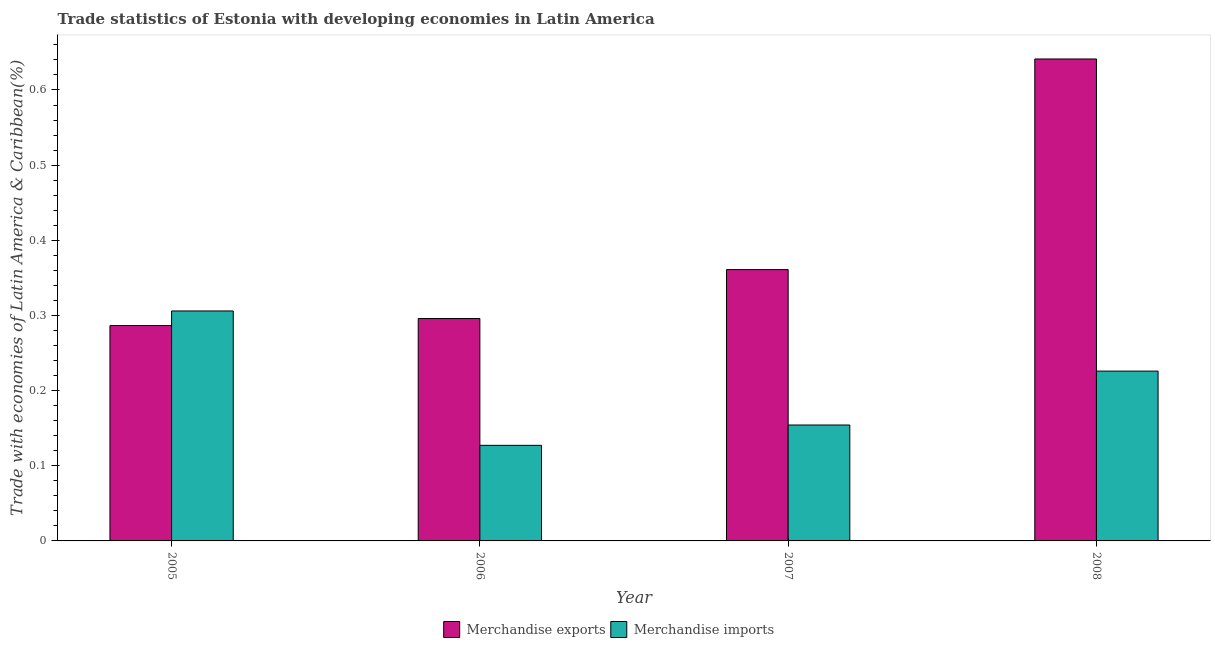How many groups of bars are there?
Keep it short and to the point. 4. How many bars are there on the 4th tick from the right?
Offer a terse response. 2. What is the label of the 2nd group of bars from the left?
Provide a short and direct response. 2006. In how many cases, is the number of bars for a given year not equal to the number of legend labels?
Your answer should be very brief. 0. What is the merchandise exports in 2007?
Your response must be concise. 0.36. Across all years, what is the maximum merchandise imports?
Provide a succinct answer. 0.31. Across all years, what is the minimum merchandise imports?
Provide a short and direct response. 0.13. What is the total merchandise imports in the graph?
Your answer should be compact. 0.81. What is the difference between the merchandise exports in 2005 and that in 2007?
Give a very brief answer. -0.07. What is the difference between the merchandise imports in 2006 and the merchandise exports in 2007?
Keep it short and to the point. -0.03. What is the average merchandise imports per year?
Give a very brief answer. 0.2. In the year 2008, what is the difference between the merchandise imports and merchandise exports?
Ensure brevity in your answer.  0. What is the ratio of the merchandise exports in 2005 to that in 2008?
Your answer should be compact. 0.45. Is the merchandise exports in 2006 less than that in 2007?
Make the answer very short. Yes. Is the difference between the merchandise imports in 2006 and 2008 greater than the difference between the merchandise exports in 2006 and 2008?
Provide a succinct answer. No. What is the difference between the highest and the second highest merchandise imports?
Ensure brevity in your answer.  0.08. What is the difference between the highest and the lowest merchandise exports?
Make the answer very short. 0.35. In how many years, is the merchandise imports greater than the average merchandise imports taken over all years?
Make the answer very short. 2. Is the sum of the merchandise imports in 2006 and 2008 greater than the maximum merchandise exports across all years?
Your answer should be very brief. Yes. What does the 1st bar from the left in 2008 represents?
Provide a short and direct response. Merchandise exports. Are the values on the major ticks of Y-axis written in scientific E-notation?
Ensure brevity in your answer.  No. Does the graph contain any zero values?
Provide a succinct answer. No. How are the legend labels stacked?
Offer a terse response. Horizontal. What is the title of the graph?
Offer a very short reply. Trade statistics of Estonia with developing economies in Latin America. Does "Revenue" appear as one of the legend labels in the graph?
Keep it short and to the point. No. What is the label or title of the Y-axis?
Your answer should be compact. Trade with economies of Latin America & Caribbean(%). What is the Trade with economies of Latin America & Caribbean(%) of Merchandise exports in 2005?
Your answer should be very brief. 0.29. What is the Trade with economies of Latin America & Caribbean(%) of Merchandise imports in 2005?
Give a very brief answer. 0.31. What is the Trade with economies of Latin America & Caribbean(%) of Merchandise exports in 2006?
Your answer should be compact. 0.3. What is the Trade with economies of Latin America & Caribbean(%) of Merchandise imports in 2006?
Provide a succinct answer. 0.13. What is the Trade with economies of Latin America & Caribbean(%) of Merchandise exports in 2007?
Provide a succinct answer. 0.36. What is the Trade with economies of Latin America & Caribbean(%) in Merchandise imports in 2007?
Offer a terse response. 0.15. What is the Trade with economies of Latin America & Caribbean(%) in Merchandise exports in 2008?
Offer a very short reply. 0.64. What is the Trade with economies of Latin America & Caribbean(%) of Merchandise imports in 2008?
Provide a short and direct response. 0.23. Across all years, what is the maximum Trade with economies of Latin America & Caribbean(%) of Merchandise exports?
Keep it short and to the point. 0.64. Across all years, what is the maximum Trade with economies of Latin America & Caribbean(%) in Merchandise imports?
Offer a terse response. 0.31. Across all years, what is the minimum Trade with economies of Latin America & Caribbean(%) of Merchandise exports?
Your answer should be very brief. 0.29. Across all years, what is the minimum Trade with economies of Latin America & Caribbean(%) in Merchandise imports?
Offer a very short reply. 0.13. What is the total Trade with economies of Latin America & Caribbean(%) of Merchandise exports in the graph?
Make the answer very short. 1.58. What is the total Trade with economies of Latin America & Caribbean(%) of Merchandise imports in the graph?
Your answer should be compact. 0.81. What is the difference between the Trade with economies of Latin America & Caribbean(%) in Merchandise exports in 2005 and that in 2006?
Provide a succinct answer. -0.01. What is the difference between the Trade with economies of Latin America & Caribbean(%) in Merchandise imports in 2005 and that in 2006?
Ensure brevity in your answer.  0.18. What is the difference between the Trade with economies of Latin America & Caribbean(%) of Merchandise exports in 2005 and that in 2007?
Provide a succinct answer. -0.07. What is the difference between the Trade with economies of Latin America & Caribbean(%) of Merchandise imports in 2005 and that in 2007?
Offer a very short reply. 0.15. What is the difference between the Trade with economies of Latin America & Caribbean(%) in Merchandise exports in 2005 and that in 2008?
Offer a terse response. -0.35. What is the difference between the Trade with economies of Latin America & Caribbean(%) in Merchandise imports in 2005 and that in 2008?
Your answer should be very brief. 0.08. What is the difference between the Trade with economies of Latin America & Caribbean(%) in Merchandise exports in 2006 and that in 2007?
Keep it short and to the point. -0.07. What is the difference between the Trade with economies of Latin America & Caribbean(%) of Merchandise imports in 2006 and that in 2007?
Your answer should be very brief. -0.03. What is the difference between the Trade with economies of Latin America & Caribbean(%) of Merchandise exports in 2006 and that in 2008?
Your answer should be very brief. -0.35. What is the difference between the Trade with economies of Latin America & Caribbean(%) in Merchandise imports in 2006 and that in 2008?
Offer a terse response. -0.1. What is the difference between the Trade with economies of Latin America & Caribbean(%) of Merchandise exports in 2007 and that in 2008?
Your response must be concise. -0.28. What is the difference between the Trade with economies of Latin America & Caribbean(%) in Merchandise imports in 2007 and that in 2008?
Ensure brevity in your answer.  -0.07. What is the difference between the Trade with economies of Latin America & Caribbean(%) of Merchandise exports in 2005 and the Trade with economies of Latin America & Caribbean(%) of Merchandise imports in 2006?
Your answer should be very brief. 0.16. What is the difference between the Trade with economies of Latin America & Caribbean(%) of Merchandise exports in 2005 and the Trade with economies of Latin America & Caribbean(%) of Merchandise imports in 2007?
Your response must be concise. 0.13. What is the difference between the Trade with economies of Latin America & Caribbean(%) in Merchandise exports in 2005 and the Trade with economies of Latin America & Caribbean(%) in Merchandise imports in 2008?
Make the answer very short. 0.06. What is the difference between the Trade with economies of Latin America & Caribbean(%) of Merchandise exports in 2006 and the Trade with economies of Latin America & Caribbean(%) of Merchandise imports in 2007?
Keep it short and to the point. 0.14. What is the difference between the Trade with economies of Latin America & Caribbean(%) in Merchandise exports in 2006 and the Trade with economies of Latin America & Caribbean(%) in Merchandise imports in 2008?
Your answer should be very brief. 0.07. What is the difference between the Trade with economies of Latin America & Caribbean(%) in Merchandise exports in 2007 and the Trade with economies of Latin America & Caribbean(%) in Merchandise imports in 2008?
Your answer should be compact. 0.14. What is the average Trade with economies of Latin America & Caribbean(%) in Merchandise exports per year?
Make the answer very short. 0.4. What is the average Trade with economies of Latin America & Caribbean(%) in Merchandise imports per year?
Offer a terse response. 0.2. In the year 2005, what is the difference between the Trade with economies of Latin America & Caribbean(%) of Merchandise exports and Trade with economies of Latin America & Caribbean(%) of Merchandise imports?
Your answer should be compact. -0.02. In the year 2006, what is the difference between the Trade with economies of Latin America & Caribbean(%) in Merchandise exports and Trade with economies of Latin America & Caribbean(%) in Merchandise imports?
Ensure brevity in your answer.  0.17. In the year 2007, what is the difference between the Trade with economies of Latin America & Caribbean(%) of Merchandise exports and Trade with economies of Latin America & Caribbean(%) of Merchandise imports?
Your response must be concise. 0.21. In the year 2008, what is the difference between the Trade with economies of Latin America & Caribbean(%) in Merchandise exports and Trade with economies of Latin America & Caribbean(%) in Merchandise imports?
Offer a very short reply. 0.42. What is the ratio of the Trade with economies of Latin America & Caribbean(%) of Merchandise exports in 2005 to that in 2006?
Your response must be concise. 0.97. What is the ratio of the Trade with economies of Latin America & Caribbean(%) of Merchandise imports in 2005 to that in 2006?
Make the answer very short. 2.41. What is the ratio of the Trade with economies of Latin America & Caribbean(%) in Merchandise exports in 2005 to that in 2007?
Your response must be concise. 0.79. What is the ratio of the Trade with economies of Latin America & Caribbean(%) in Merchandise imports in 2005 to that in 2007?
Offer a very short reply. 1.98. What is the ratio of the Trade with economies of Latin America & Caribbean(%) in Merchandise exports in 2005 to that in 2008?
Your answer should be compact. 0.45. What is the ratio of the Trade with economies of Latin America & Caribbean(%) of Merchandise imports in 2005 to that in 2008?
Make the answer very short. 1.35. What is the ratio of the Trade with economies of Latin America & Caribbean(%) of Merchandise exports in 2006 to that in 2007?
Your answer should be compact. 0.82. What is the ratio of the Trade with economies of Latin America & Caribbean(%) of Merchandise imports in 2006 to that in 2007?
Make the answer very short. 0.82. What is the ratio of the Trade with economies of Latin America & Caribbean(%) of Merchandise exports in 2006 to that in 2008?
Your answer should be compact. 0.46. What is the ratio of the Trade with economies of Latin America & Caribbean(%) of Merchandise imports in 2006 to that in 2008?
Your answer should be compact. 0.56. What is the ratio of the Trade with economies of Latin America & Caribbean(%) in Merchandise exports in 2007 to that in 2008?
Keep it short and to the point. 0.56. What is the ratio of the Trade with economies of Latin America & Caribbean(%) of Merchandise imports in 2007 to that in 2008?
Your response must be concise. 0.68. What is the difference between the highest and the second highest Trade with economies of Latin America & Caribbean(%) of Merchandise exports?
Make the answer very short. 0.28. What is the difference between the highest and the lowest Trade with economies of Latin America & Caribbean(%) in Merchandise exports?
Provide a succinct answer. 0.35. What is the difference between the highest and the lowest Trade with economies of Latin America & Caribbean(%) in Merchandise imports?
Offer a terse response. 0.18. 